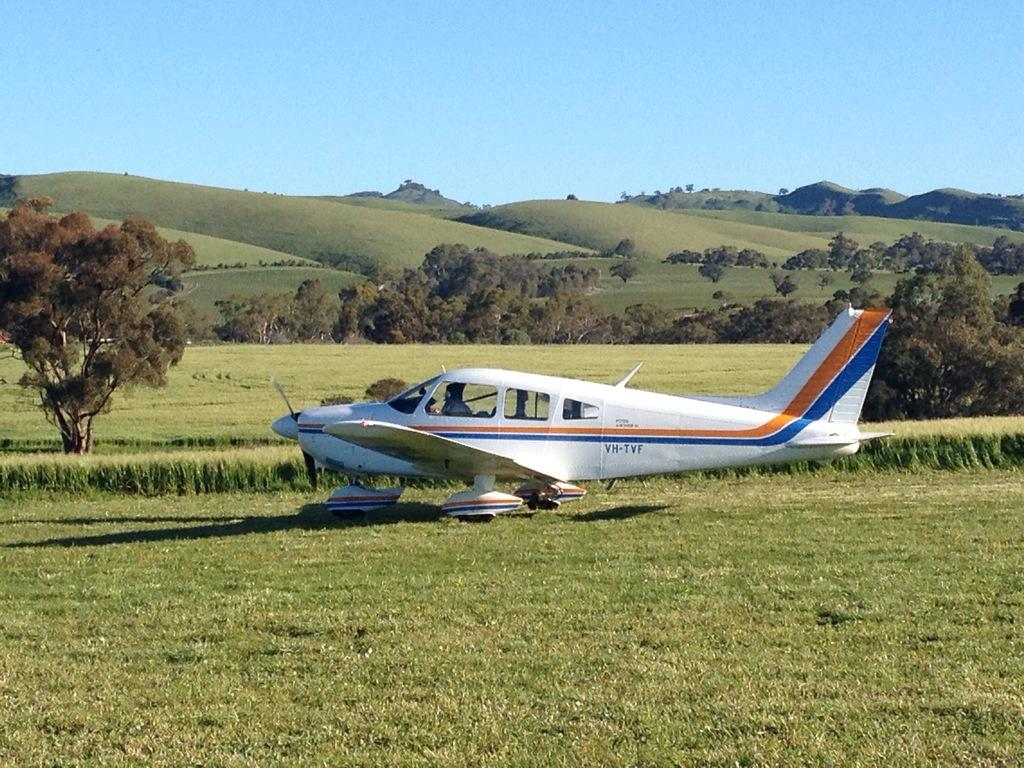What is the main subject of the image? The main subject of the image is an airplane. Where is the airplane located? The airplane is on the grass. What type of vegetation can be seen in the image? There are trees in the image. What can be seen in the background of the image? There are mountains and the sky visible in the background of the image. What type of debt is being discussed in the image? There is no mention of debt in the image; it features an airplane on the grass with trees and mountains in the background. How many elbows can be seen in the image? There are no elbows visible in the image. 